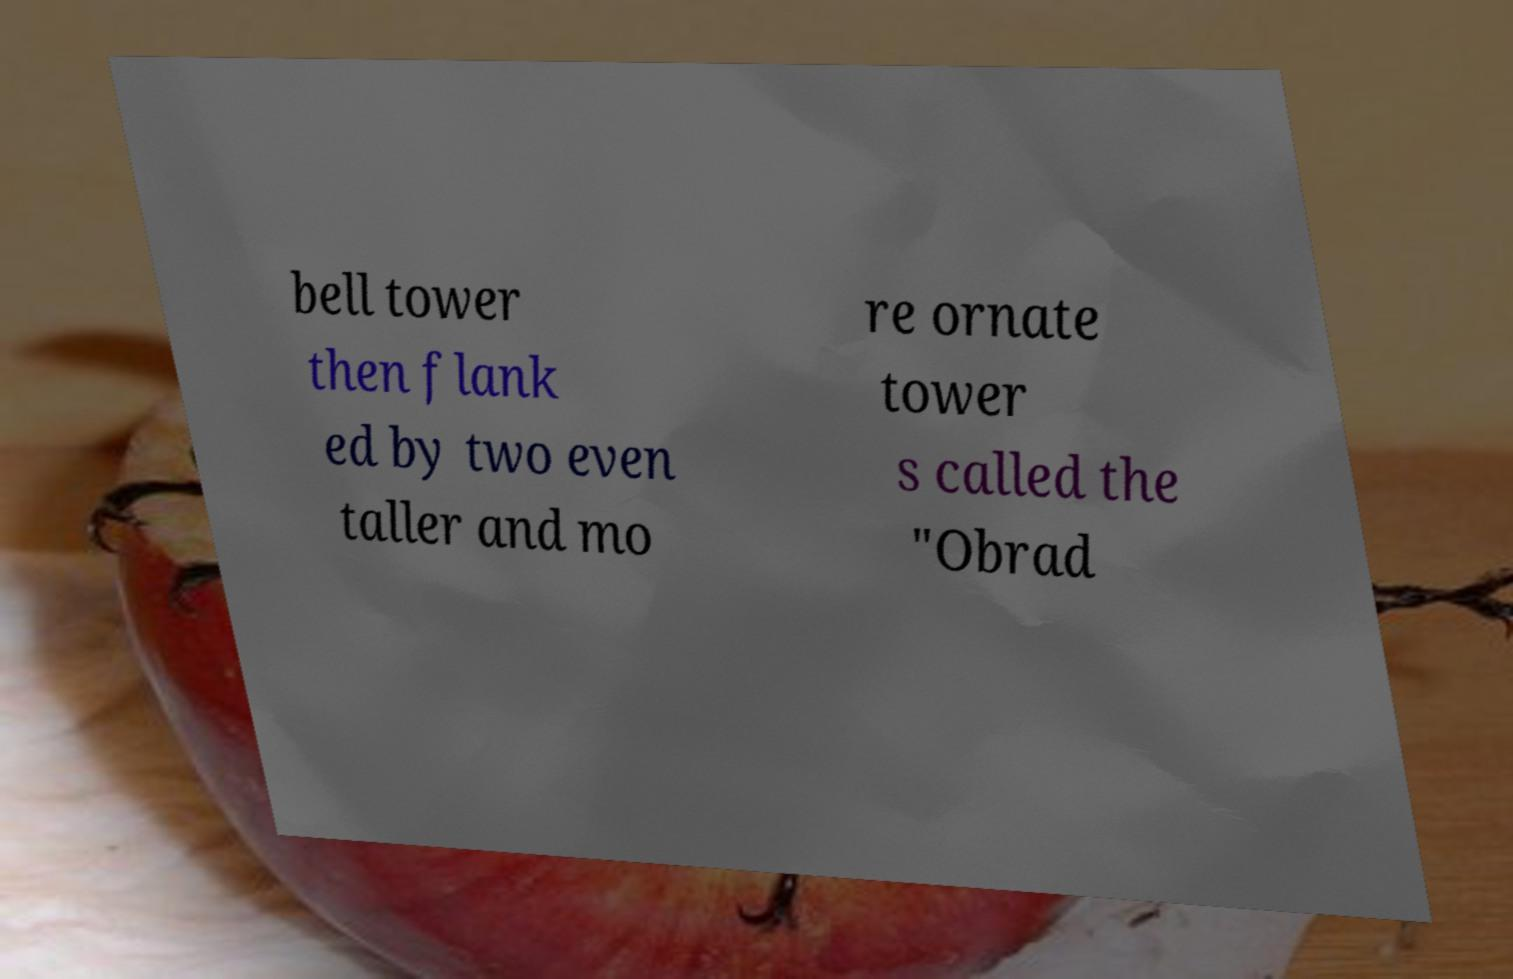Please identify and transcribe the text found in this image. bell tower then flank ed by two even taller and mo re ornate tower s called the "Obrad 